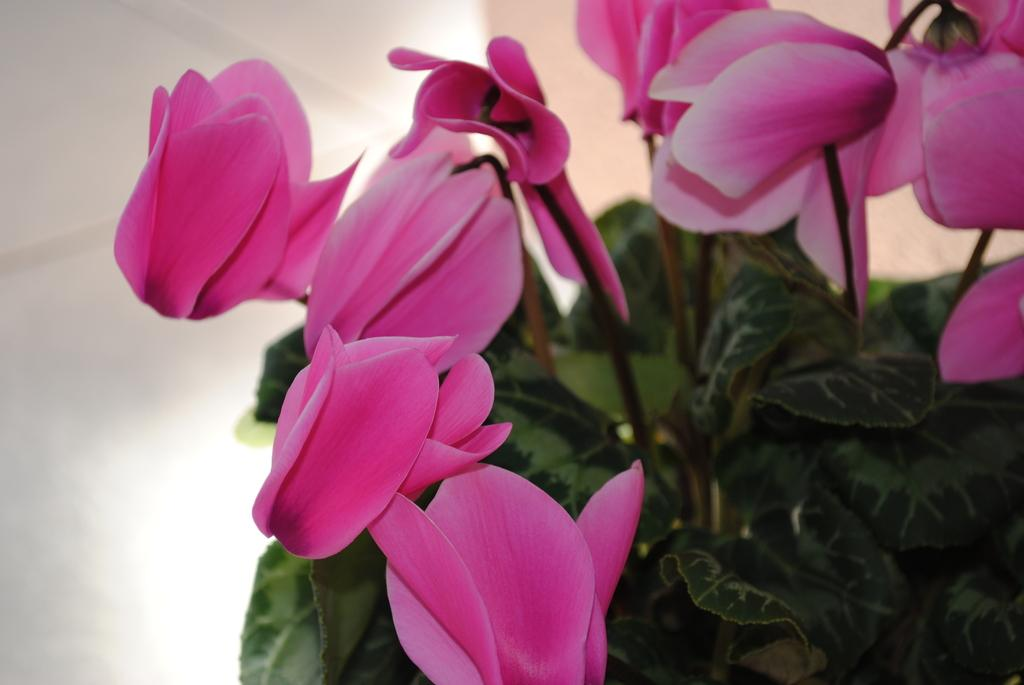What type of living organisms can be seen in the image? There are flowers in the image. What color are the flowers in the image? The flowers are pink in color. Can you see a nest with eggs in the image? There is no nest or eggs present in the image; it features pink flowers. 